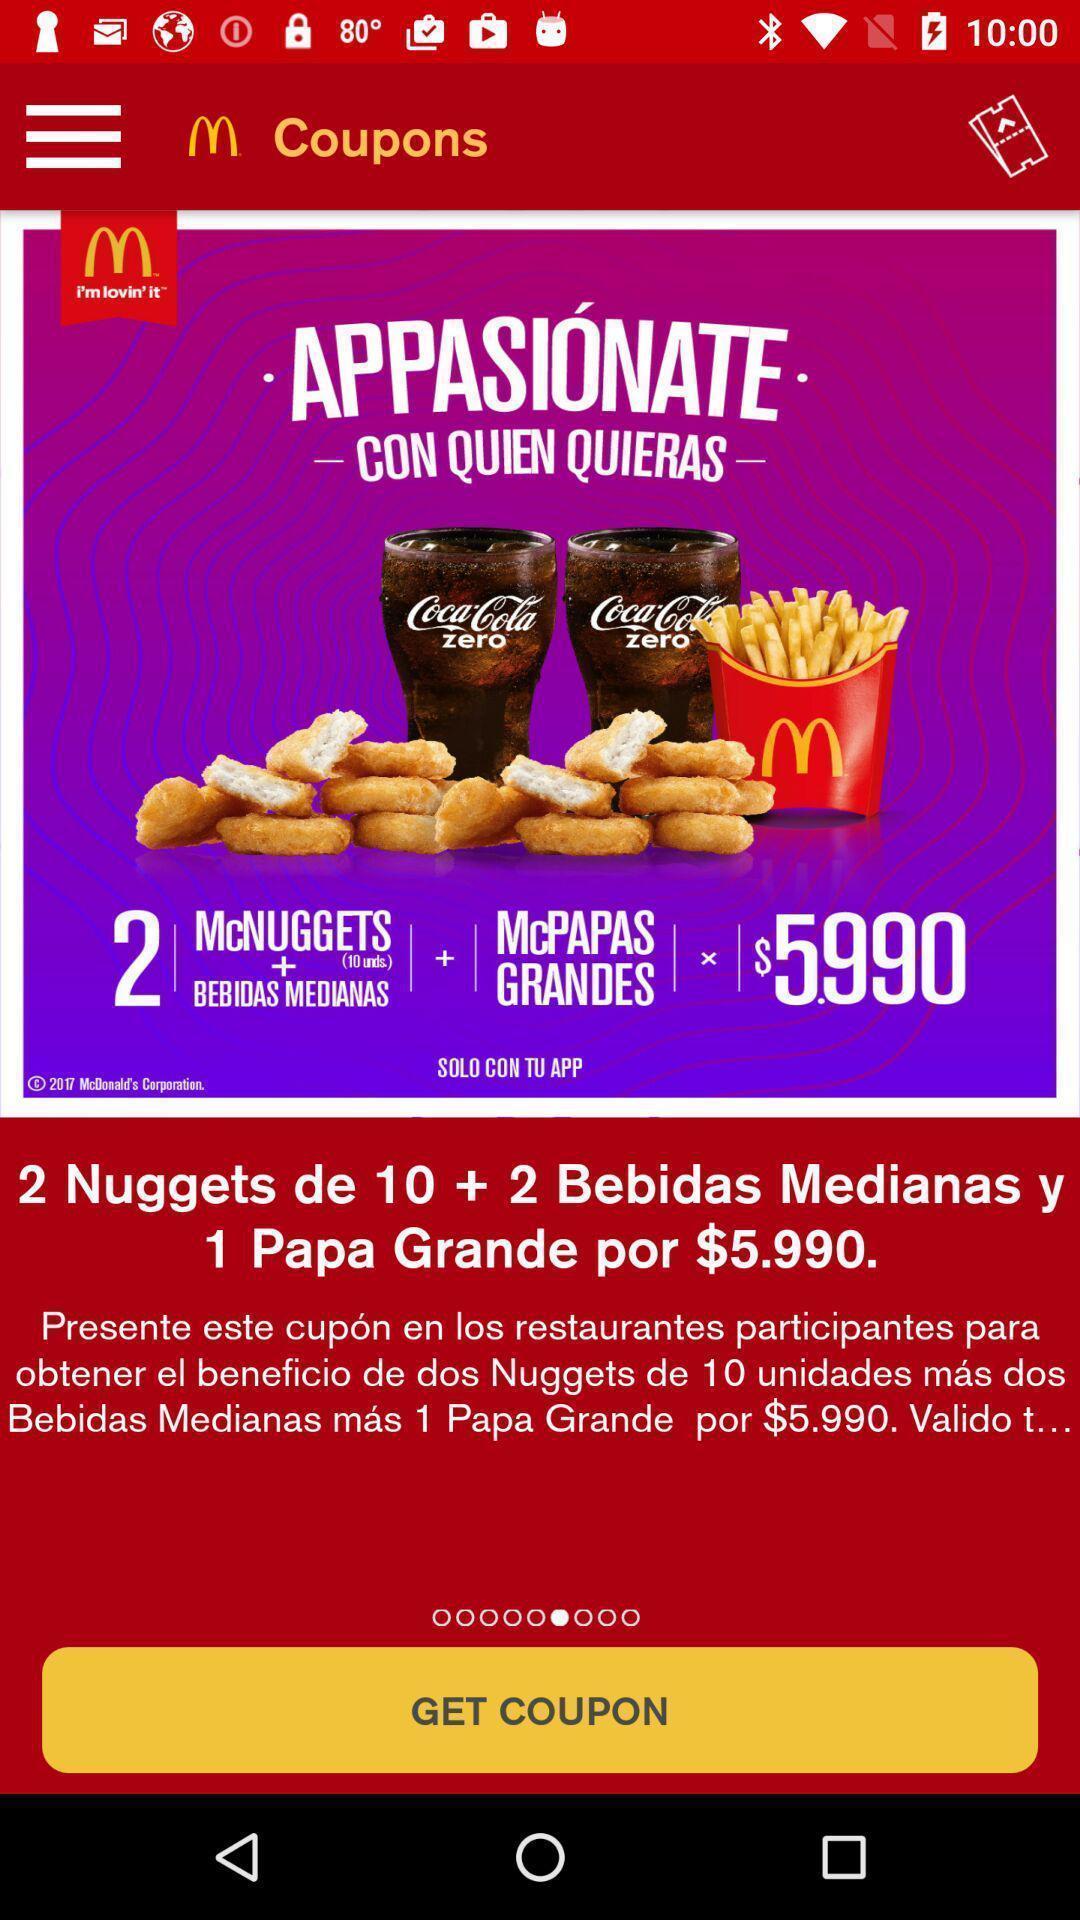Provide a description of this screenshot. Page displaying to get coupon in food app. 